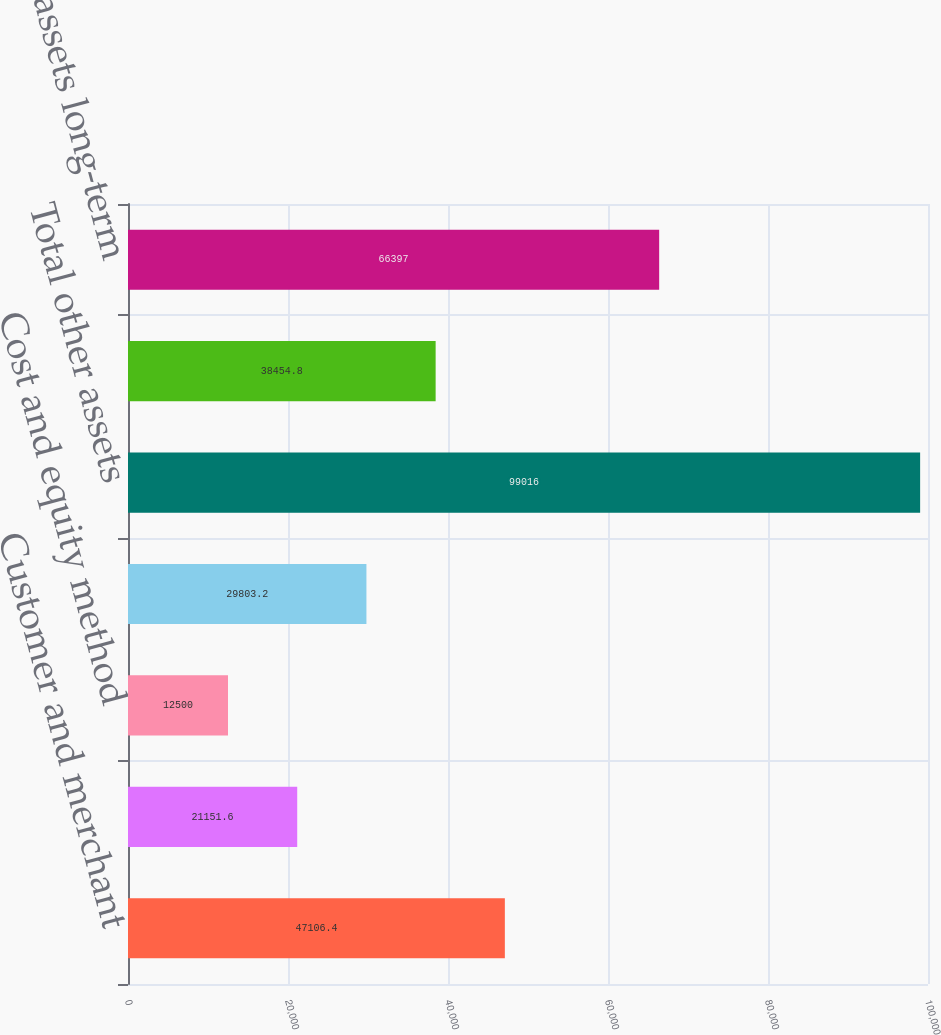Convert chart. <chart><loc_0><loc_0><loc_500><loc_500><bar_chart><fcel>Customer and merchant<fcel>Cash surrender value of keyman<fcel>Cost and equity method<fcel>Other<fcel>Total other assets<fcel>Other assets current<fcel>Other assets long-term<nl><fcel>47106.4<fcel>21151.6<fcel>12500<fcel>29803.2<fcel>99016<fcel>38454.8<fcel>66397<nl></chart> 